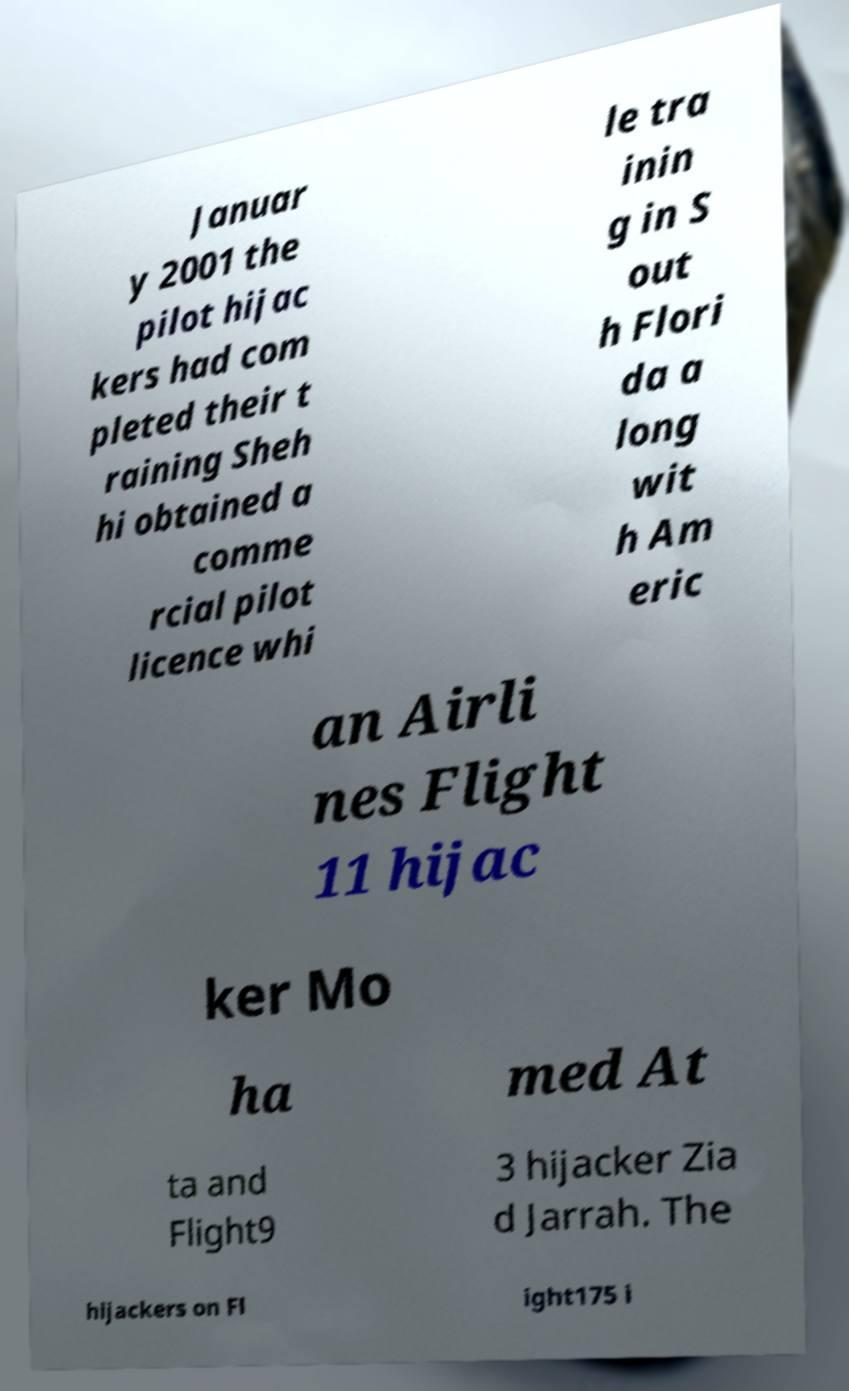There's text embedded in this image that I need extracted. Can you transcribe it verbatim? Januar y 2001 the pilot hijac kers had com pleted their t raining Sheh hi obtained a comme rcial pilot licence whi le tra inin g in S out h Flori da a long wit h Am eric an Airli nes Flight 11 hijac ker Mo ha med At ta and Flight9 3 hijacker Zia d Jarrah. The hijackers on Fl ight175 i 